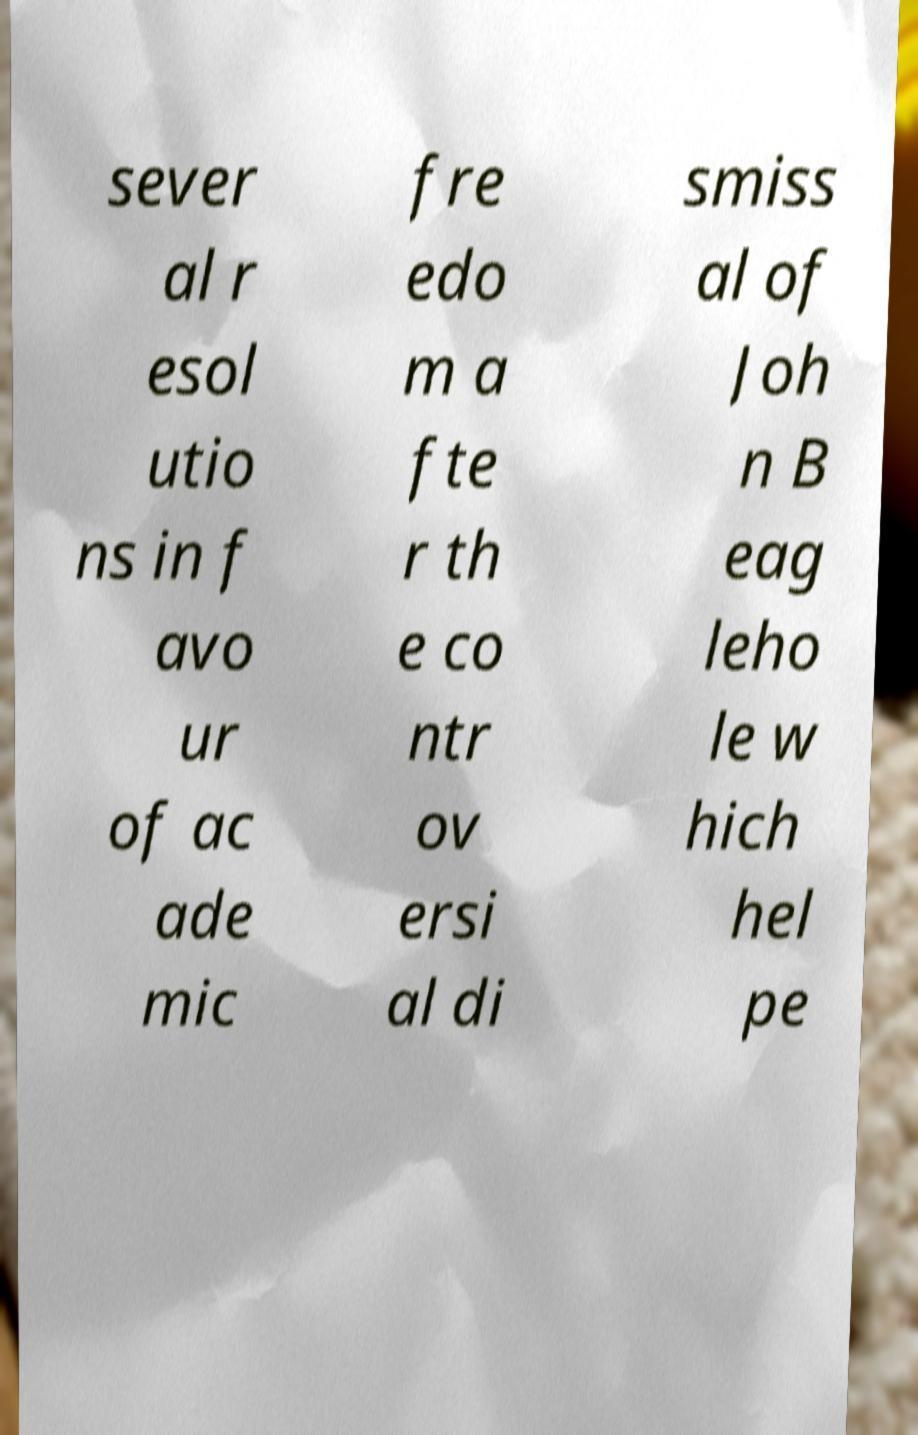For documentation purposes, I need the text within this image transcribed. Could you provide that? sever al r esol utio ns in f avo ur of ac ade mic fre edo m a fte r th e co ntr ov ersi al di smiss al of Joh n B eag leho le w hich hel pe 